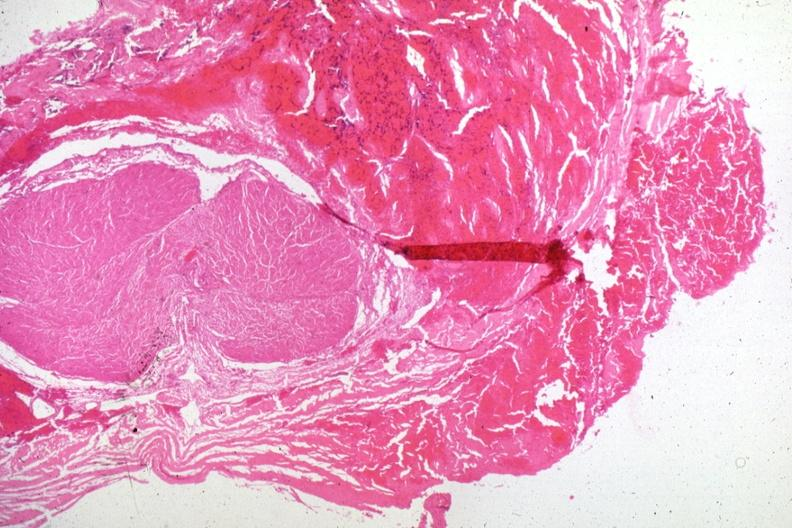what does this image show?
Answer the question using a single word or phrase. Hemorrhagic tissue in region of lesion several slides on case 